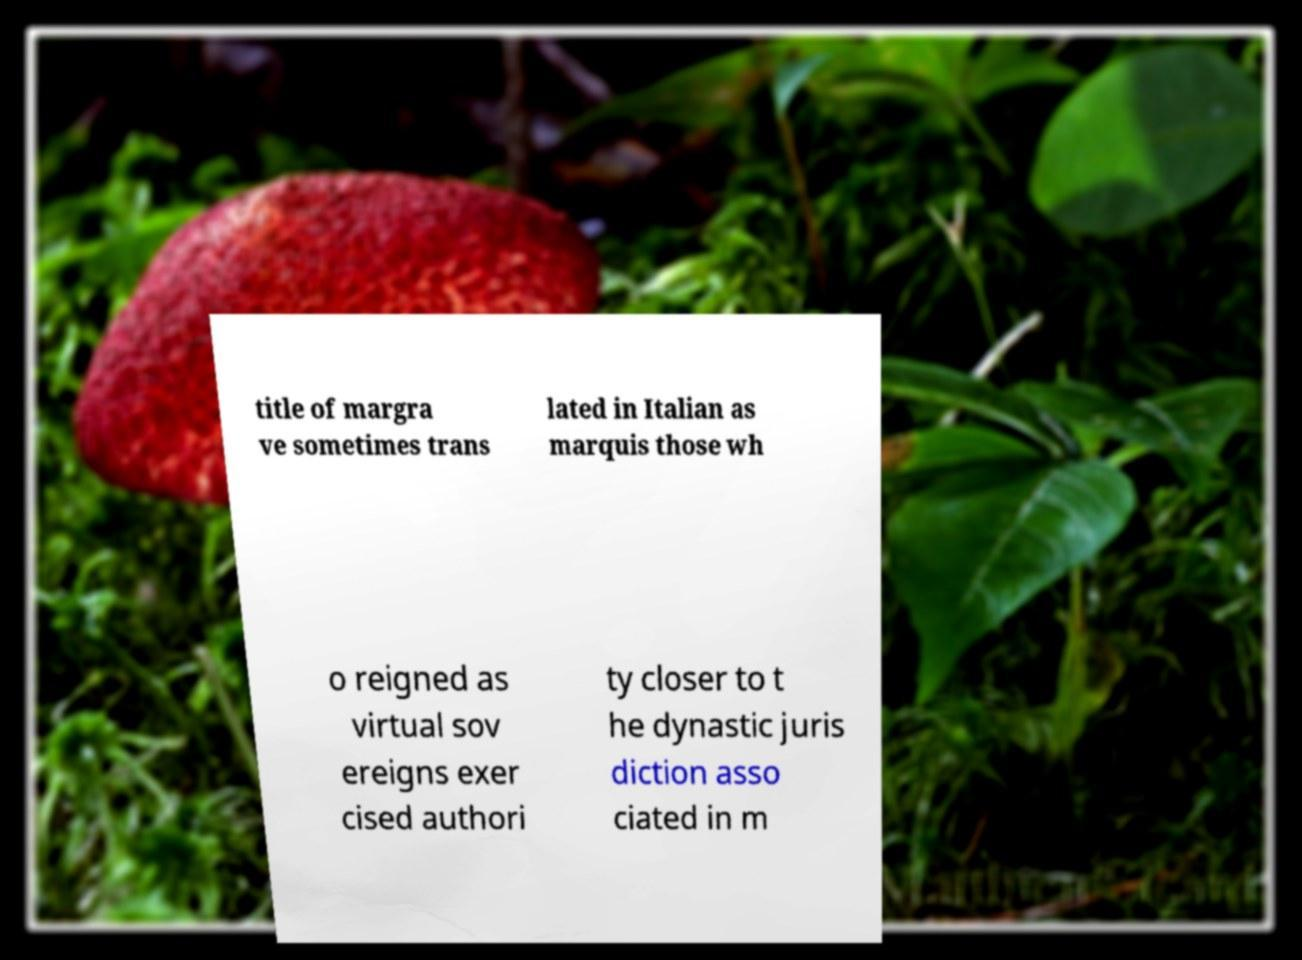Could you assist in decoding the text presented in this image and type it out clearly? title of margra ve sometimes trans lated in Italian as marquis those wh o reigned as virtual sov ereigns exer cised authori ty closer to t he dynastic juris diction asso ciated in m 